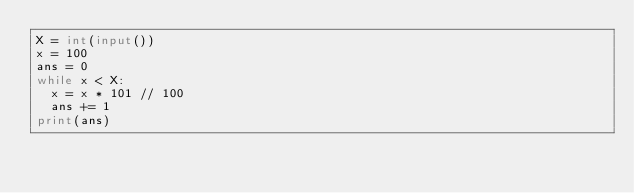Convert code to text. <code><loc_0><loc_0><loc_500><loc_500><_Python_>X = int(input())
x = 100
ans = 0
while x < X:
  x = x * 101 // 100
  ans += 1
print(ans)</code> 